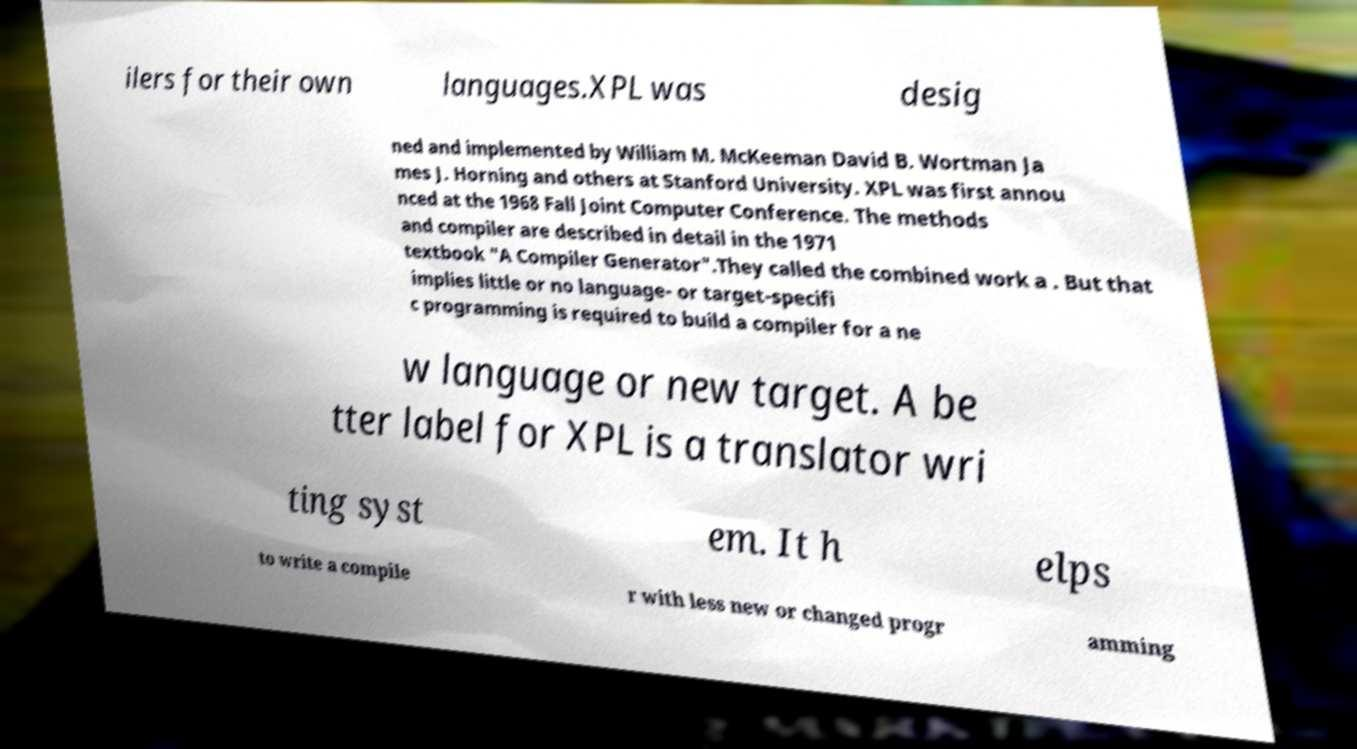What messages or text are displayed in this image? I need them in a readable, typed format. ilers for their own languages.XPL was desig ned and implemented by William M. McKeeman David B. Wortman Ja mes J. Horning and others at Stanford University. XPL was first annou nced at the 1968 Fall Joint Computer Conference. The methods and compiler are described in detail in the 1971 textbook "A Compiler Generator".They called the combined work a . But that implies little or no language- or target-specifi c programming is required to build a compiler for a ne w language or new target. A be tter label for XPL is a translator wri ting syst em. It h elps to write a compile r with less new or changed progr amming 